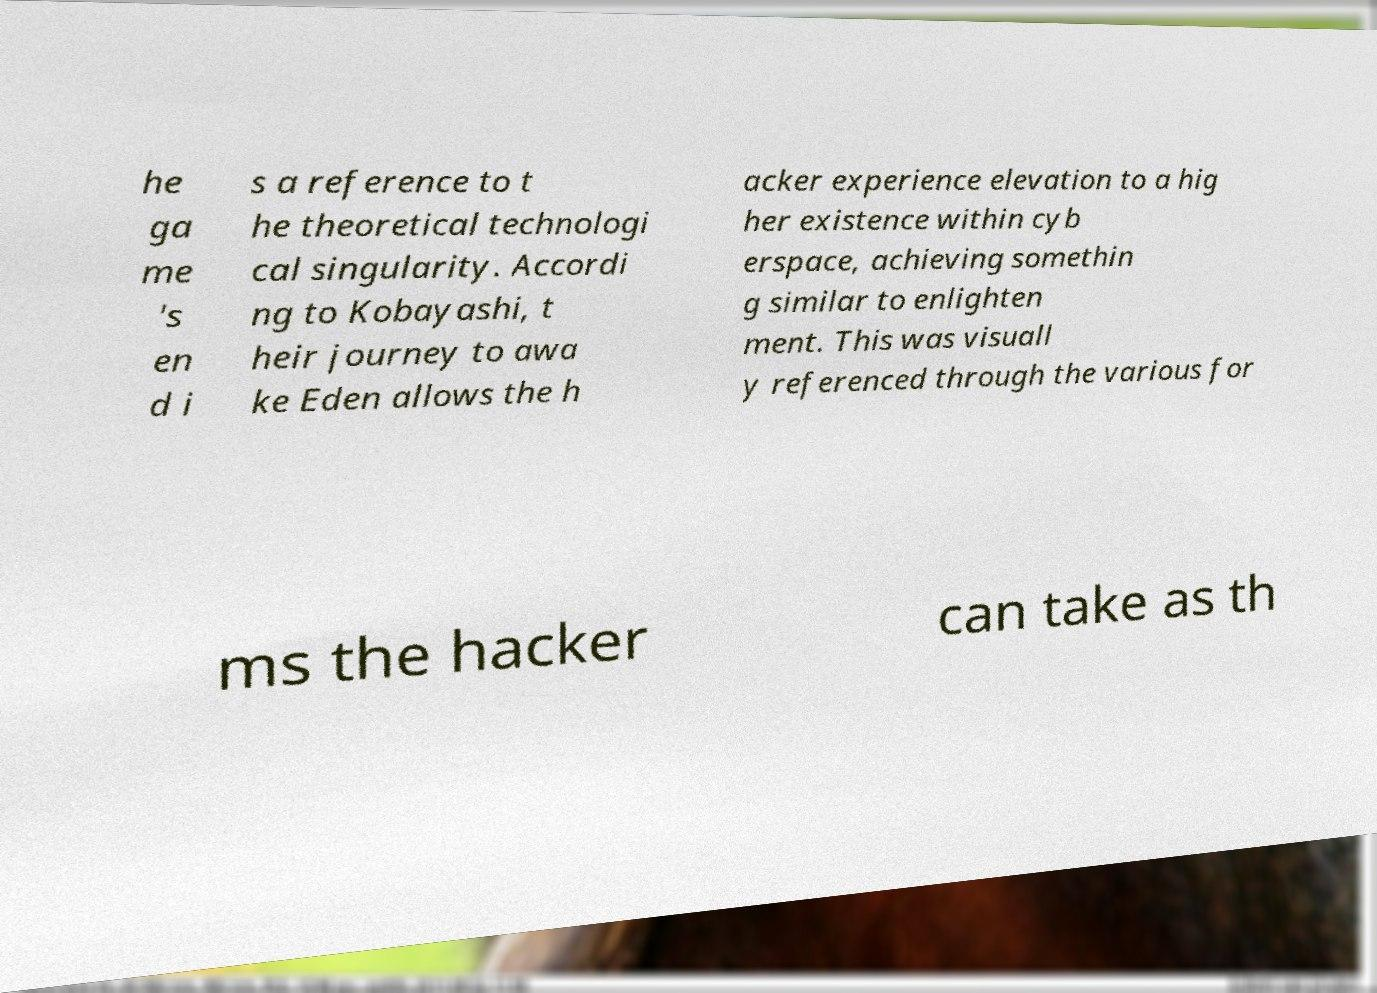There's text embedded in this image that I need extracted. Can you transcribe it verbatim? he ga me 's en d i s a reference to t he theoretical technologi cal singularity. Accordi ng to Kobayashi, t heir journey to awa ke Eden allows the h acker experience elevation to a hig her existence within cyb erspace, achieving somethin g similar to enlighten ment. This was visuall y referenced through the various for ms the hacker can take as th 